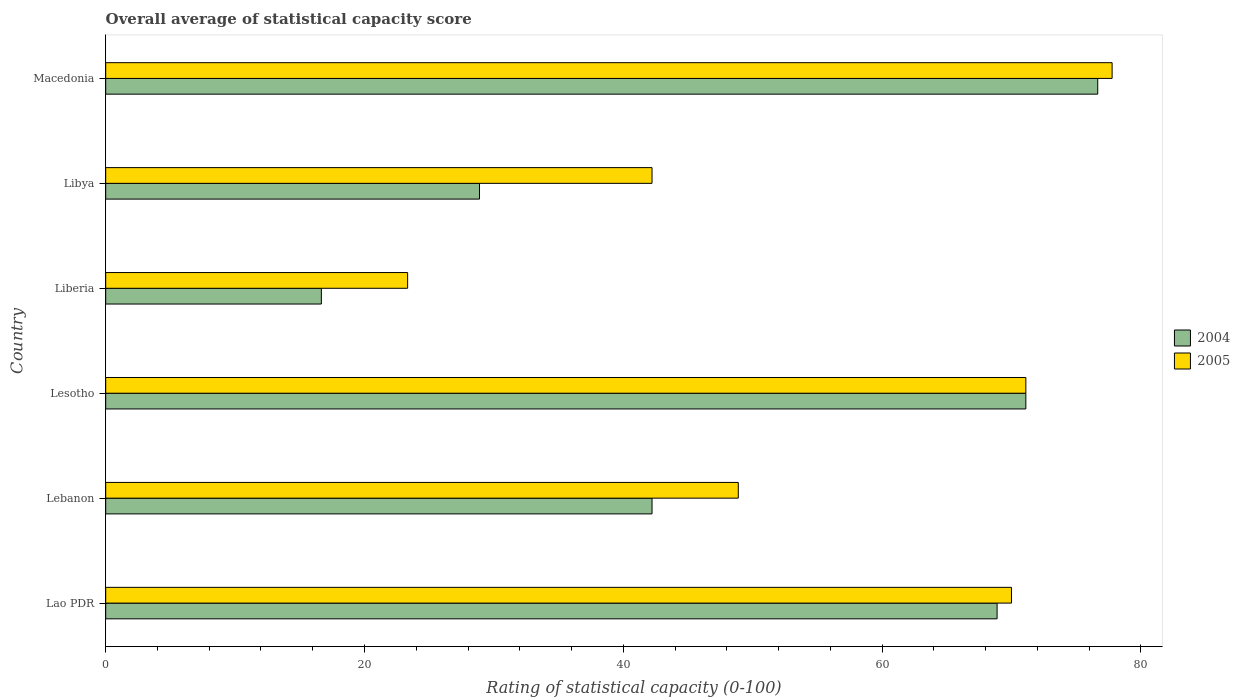How many different coloured bars are there?
Offer a terse response. 2. Are the number of bars on each tick of the Y-axis equal?
Offer a very short reply. Yes. How many bars are there on the 1st tick from the top?
Offer a terse response. 2. How many bars are there on the 2nd tick from the bottom?
Your response must be concise. 2. What is the label of the 2nd group of bars from the top?
Provide a succinct answer. Libya. In how many cases, is the number of bars for a given country not equal to the number of legend labels?
Provide a short and direct response. 0. What is the rating of statistical capacity in 2005 in Liberia?
Your answer should be very brief. 23.33. Across all countries, what is the maximum rating of statistical capacity in 2004?
Your response must be concise. 76.67. Across all countries, what is the minimum rating of statistical capacity in 2005?
Ensure brevity in your answer.  23.33. In which country was the rating of statistical capacity in 2004 maximum?
Your answer should be compact. Macedonia. In which country was the rating of statistical capacity in 2004 minimum?
Provide a short and direct response. Liberia. What is the total rating of statistical capacity in 2005 in the graph?
Make the answer very short. 333.33. What is the difference between the rating of statistical capacity in 2005 in Lebanon and that in Liberia?
Provide a succinct answer. 25.56. What is the difference between the rating of statistical capacity in 2004 in Lebanon and the rating of statistical capacity in 2005 in Lesotho?
Keep it short and to the point. -28.89. What is the average rating of statistical capacity in 2005 per country?
Provide a succinct answer. 55.56. What is the difference between the rating of statistical capacity in 2005 and rating of statistical capacity in 2004 in Lebanon?
Give a very brief answer. 6.67. In how many countries, is the rating of statistical capacity in 2004 greater than 64 ?
Offer a terse response. 3. What is the ratio of the rating of statistical capacity in 2005 in Lao PDR to that in Libya?
Offer a very short reply. 1.66. Is the rating of statistical capacity in 2004 in Libya less than that in Macedonia?
Provide a short and direct response. Yes. Is the difference between the rating of statistical capacity in 2005 in Lao PDR and Libya greater than the difference between the rating of statistical capacity in 2004 in Lao PDR and Libya?
Your answer should be very brief. No. What is the difference between the highest and the second highest rating of statistical capacity in 2004?
Provide a succinct answer. 5.56. What is the difference between the highest and the lowest rating of statistical capacity in 2005?
Your answer should be very brief. 54.44. In how many countries, is the rating of statistical capacity in 2004 greater than the average rating of statistical capacity in 2004 taken over all countries?
Your answer should be very brief. 3. Is the sum of the rating of statistical capacity in 2004 in Liberia and Libya greater than the maximum rating of statistical capacity in 2005 across all countries?
Make the answer very short. No. What does the 1st bar from the top in Libya represents?
Your answer should be compact. 2005. What does the 2nd bar from the bottom in Macedonia represents?
Offer a very short reply. 2005. How many bars are there?
Make the answer very short. 12. How many countries are there in the graph?
Your answer should be very brief. 6. What is the difference between two consecutive major ticks on the X-axis?
Offer a very short reply. 20. Are the values on the major ticks of X-axis written in scientific E-notation?
Provide a succinct answer. No. Does the graph contain grids?
Provide a succinct answer. No. Where does the legend appear in the graph?
Provide a succinct answer. Center right. How many legend labels are there?
Ensure brevity in your answer.  2. How are the legend labels stacked?
Provide a succinct answer. Vertical. What is the title of the graph?
Keep it short and to the point. Overall average of statistical capacity score. What is the label or title of the X-axis?
Your response must be concise. Rating of statistical capacity (0-100). What is the Rating of statistical capacity (0-100) of 2004 in Lao PDR?
Your response must be concise. 68.89. What is the Rating of statistical capacity (0-100) in 2005 in Lao PDR?
Ensure brevity in your answer.  70. What is the Rating of statistical capacity (0-100) of 2004 in Lebanon?
Ensure brevity in your answer.  42.22. What is the Rating of statistical capacity (0-100) of 2005 in Lebanon?
Give a very brief answer. 48.89. What is the Rating of statistical capacity (0-100) of 2004 in Lesotho?
Provide a succinct answer. 71.11. What is the Rating of statistical capacity (0-100) in 2005 in Lesotho?
Offer a very short reply. 71.11. What is the Rating of statistical capacity (0-100) of 2004 in Liberia?
Offer a terse response. 16.67. What is the Rating of statistical capacity (0-100) of 2005 in Liberia?
Offer a very short reply. 23.33. What is the Rating of statistical capacity (0-100) in 2004 in Libya?
Your response must be concise. 28.89. What is the Rating of statistical capacity (0-100) in 2005 in Libya?
Offer a terse response. 42.22. What is the Rating of statistical capacity (0-100) of 2004 in Macedonia?
Your answer should be compact. 76.67. What is the Rating of statistical capacity (0-100) of 2005 in Macedonia?
Give a very brief answer. 77.78. Across all countries, what is the maximum Rating of statistical capacity (0-100) in 2004?
Keep it short and to the point. 76.67. Across all countries, what is the maximum Rating of statistical capacity (0-100) in 2005?
Make the answer very short. 77.78. Across all countries, what is the minimum Rating of statistical capacity (0-100) of 2004?
Offer a terse response. 16.67. Across all countries, what is the minimum Rating of statistical capacity (0-100) in 2005?
Your response must be concise. 23.33. What is the total Rating of statistical capacity (0-100) of 2004 in the graph?
Your answer should be compact. 304.44. What is the total Rating of statistical capacity (0-100) in 2005 in the graph?
Your answer should be compact. 333.33. What is the difference between the Rating of statistical capacity (0-100) in 2004 in Lao PDR and that in Lebanon?
Make the answer very short. 26.67. What is the difference between the Rating of statistical capacity (0-100) in 2005 in Lao PDR and that in Lebanon?
Your response must be concise. 21.11. What is the difference between the Rating of statistical capacity (0-100) of 2004 in Lao PDR and that in Lesotho?
Make the answer very short. -2.22. What is the difference between the Rating of statistical capacity (0-100) of 2005 in Lao PDR and that in Lesotho?
Offer a very short reply. -1.11. What is the difference between the Rating of statistical capacity (0-100) of 2004 in Lao PDR and that in Liberia?
Provide a short and direct response. 52.22. What is the difference between the Rating of statistical capacity (0-100) in 2005 in Lao PDR and that in Liberia?
Your answer should be compact. 46.67. What is the difference between the Rating of statistical capacity (0-100) of 2004 in Lao PDR and that in Libya?
Your response must be concise. 40. What is the difference between the Rating of statistical capacity (0-100) in 2005 in Lao PDR and that in Libya?
Offer a terse response. 27.78. What is the difference between the Rating of statistical capacity (0-100) in 2004 in Lao PDR and that in Macedonia?
Offer a very short reply. -7.78. What is the difference between the Rating of statistical capacity (0-100) of 2005 in Lao PDR and that in Macedonia?
Provide a short and direct response. -7.78. What is the difference between the Rating of statistical capacity (0-100) of 2004 in Lebanon and that in Lesotho?
Offer a very short reply. -28.89. What is the difference between the Rating of statistical capacity (0-100) of 2005 in Lebanon and that in Lesotho?
Provide a succinct answer. -22.22. What is the difference between the Rating of statistical capacity (0-100) of 2004 in Lebanon and that in Liberia?
Give a very brief answer. 25.56. What is the difference between the Rating of statistical capacity (0-100) of 2005 in Lebanon and that in Liberia?
Offer a very short reply. 25.56. What is the difference between the Rating of statistical capacity (0-100) in 2004 in Lebanon and that in Libya?
Your answer should be compact. 13.33. What is the difference between the Rating of statistical capacity (0-100) of 2005 in Lebanon and that in Libya?
Give a very brief answer. 6.67. What is the difference between the Rating of statistical capacity (0-100) of 2004 in Lebanon and that in Macedonia?
Your response must be concise. -34.44. What is the difference between the Rating of statistical capacity (0-100) of 2005 in Lebanon and that in Macedonia?
Keep it short and to the point. -28.89. What is the difference between the Rating of statistical capacity (0-100) in 2004 in Lesotho and that in Liberia?
Offer a terse response. 54.44. What is the difference between the Rating of statistical capacity (0-100) of 2005 in Lesotho and that in Liberia?
Offer a terse response. 47.78. What is the difference between the Rating of statistical capacity (0-100) in 2004 in Lesotho and that in Libya?
Give a very brief answer. 42.22. What is the difference between the Rating of statistical capacity (0-100) in 2005 in Lesotho and that in Libya?
Your answer should be very brief. 28.89. What is the difference between the Rating of statistical capacity (0-100) in 2004 in Lesotho and that in Macedonia?
Provide a succinct answer. -5.56. What is the difference between the Rating of statistical capacity (0-100) in 2005 in Lesotho and that in Macedonia?
Your answer should be compact. -6.67. What is the difference between the Rating of statistical capacity (0-100) of 2004 in Liberia and that in Libya?
Make the answer very short. -12.22. What is the difference between the Rating of statistical capacity (0-100) in 2005 in Liberia and that in Libya?
Your response must be concise. -18.89. What is the difference between the Rating of statistical capacity (0-100) of 2004 in Liberia and that in Macedonia?
Ensure brevity in your answer.  -60. What is the difference between the Rating of statistical capacity (0-100) in 2005 in Liberia and that in Macedonia?
Offer a terse response. -54.44. What is the difference between the Rating of statistical capacity (0-100) in 2004 in Libya and that in Macedonia?
Make the answer very short. -47.78. What is the difference between the Rating of statistical capacity (0-100) of 2005 in Libya and that in Macedonia?
Ensure brevity in your answer.  -35.56. What is the difference between the Rating of statistical capacity (0-100) in 2004 in Lao PDR and the Rating of statistical capacity (0-100) in 2005 in Lesotho?
Provide a short and direct response. -2.22. What is the difference between the Rating of statistical capacity (0-100) in 2004 in Lao PDR and the Rating of statistical capacity (0-100) in 2005 in Liberia?
Provide a short and direct response. 45.56. What is the difference between the Rating of statistical capacity (0-100) in 2004 in Lao PDR and the Rating of statistical capacity (0-100) in 2005 in Libya?
Make the answer very short. 26.67. What is the difference between the Rating of statistical capacity (0-100) in 2004 in Lao PDR and the Rating of statistical capacity (0-100) in 2005 in Macedonia?
Your response must be concise. -8.89. What is the difference between the Rating of statistical capacity (0-100) of 2004 in Lebanon and the Rating of statistical capacity (0-100) of 2005 in Lesotho?
Your response must be concise. -28.89. What is the difference between the Rating of statistical capacity (0-100) in 2004 in Lebanon and the Rating of statistical capacity (0-100) in 2005 in Liberia?
Provide a succinct answer. 18.89. What is the difference between the Rating of statistical capacity (0-100) in 2004 in Lebanon and the Rating of statistical capacity (0-100) in 2005 in Libya?
Your answer should be compact. 0. What is the difference between the Rating of statistical capacity (0-100) in 2004 in Lebanon and the Rating of statistical capacity (0-100) in 2005 in Macedonia?
Provide a short and direct response. -35.56. What is the difference between the Rating of statistical capacity (0-100) in 2004 in Lesotho and the Rating of statistical capacity (0-100) in 2005 in Liberia?
Give a very brief answer. 47.78. What is the difference between the Rating of statistical capacity (0-100) in 2004 in Lesotho and the Rating of statistical capacity (0-100) in 2005 in Libya?
Keep it short and to the point. 28.89. What is the difference between the Rating of statistical capacity (0-100) in 2004 in Lesotho and the Rating of statistical capacity (0-100) in 2005 in Macedonia?
Keep it short and to the point. -6.67. What is the difference between the Rating of statistical capacity (0-100) of 2004 in Liberia and the Rating of statistical capacity (0-100) of 2005 in Libya?
Ensure brevity in your answer.  -25.56. What is the difference between the Rating of statistical capacity (0-100) in 2004 in Liberia and the Rating of statistical capacity (0-100) in 2005 in Macedonia?
Offer a very short reply. -61.11. What is the difference between the Rating of statistical capacity (0-100) of 2004 in Libya and the Rating of statistical capacity (0-100) of 2005 in Macedonia?
Give a very brief answer. -48.89. What is the average Rating of statistical capacity (0-100) in 2004 per country?
Offer a terse response. 50.74. What is the average Rating of statistical capacity (0-100) in 2005 per country?
Offer a very short reply. 55.56. What is the difference between the Rating of statistical capacity (0-100) of 2004 and Rating of statistical capacity (0-100) of 2005 in Lao PDR?
Your response must be concise. -1.11. What is the difference between the Rating of statistical capacity (0-100) of 2004 and Rating of statistical capacity (0-100) of 2005 in Lebanon?
Make the answer very short. -6.67. What is the difference between the Rating of statistical capacity (0-100) in 2004 and Rating of statistical capacity (0-100) in 2005 in Liberia?
Give a very brief answer. -6.67. What is the difference between the Rating of statistical capacity (0-100) of 2004 and Rating of statistical capacity (0-100) of 2005 in Libya?
Ensure brevity in your answer.  -13.33. What is the difference between the Rating of statistical capacity (0-100) in 2004 and Rating of statistical capacity (0-100) in 2005 in Macedonia?
Provide a short and direct response. -1.11. What is the ratio of the Rating of statistical capacity (0-100) of 2004 in Lao PDR to that in Lebanon?
Give a very brief answer. 1.63. What is the ratio of the Rating of statistical capacity (0-100) in 2005 in Lao PDR to that in Lebanon?
Make the answer very short. 1.43. What is the ratio of the Rating of statistical capacity (0-100) of 2004 in Lao PDR to that in Lesotho?
Offer a terse response. 0.97. What is the ratio of the Rating of statistical capacity (0-100) in 2005 in Lao PDR to that in Lesotho?
Give a very brief answer. 0.98. What is the ratio of the Rating of statistical capacity (0-100) of 2004 in Lao PDR to that in Liberia?
Offer a terse response. 4.13. What is the ratio of the Rating of statistical capacity (0-100) in 2005 in Lao PDR to that in Liberia?
Provide a succinct answer. 3. What is the ratio of the Rating of statistical capacity (0-100) in 2004 in Lao PDR to that in Libya?
Your answer should be compact. 2.38. What is the ratio of the Rating of statistical capacity (0-100) in 2005 in Lao PDR to that in Libya?
Your answer should be compact. 1.66. What is the ratio of the Rating of statistical capacity (0-100) in 2004 in Lao PDR to that in Macedonia?
Give a very brief answer. 0.9. What is the ratio of the Rating of statistical capacity (0-100) of 2004 in Lebanon to that in Lesotho?
Ensure brevity in your answer.  0.59. What is the ratio of the Rating of statistical capacity (0-100) in 2005 in Lebanon to that in Lesotho?
Offer a very short reply. 0.69. What is the ratio of the Rating of statistical capacity (0-100) of 2004 in Lebanon to that in Liberia?
Offer a terse response. 2.53. What is the ratio of the Rating of statistical capacity (0-100) of 2005 in Lebanon to that in Liberia?
Your response must be concise. 2.1. What is the ratio of the Rating of statistical capacity (0-100) of 2004 in Lebanon to that in Libya?
Your response must be concise. 1.46. What is the ratio of the Rating of statistical capacity (0-100) in 2005 in Lebanon to that in Libya?
Offer a very short reply. 1.16. What is the ratio of the Rating of statistical capacity (0-100) in 2004 in Lebanon to that in Macedonia?
Your response must be concise. 0.55. What is the ratio of the Rating of statistical capacity (0-100) in 2005 in Lebanon to that in Macedonia?
Your response must be concise. 0.63. What is the ratio of the Rating of statistical capacity (0-100) in 2004 in Lesotho to that in Liberia?
Offer a terse response. 4.27. What is the ratio of the Rating of statistical capacity (0-100) in 2005 in Lesotho to that in Liberia?
Make the answer very short. 3.05. What is the ratio of the Rating of statistical capacity (0-100) in 2004 in Lesotho to that in Libya?
Give a very brief answer. 2.46. What is the ratio of the Rating of statistical capacity (0-100) of 2005 in Lesotho to that in Libya?
Provide a short and direct response. 1.68. What is the ratio of the Rating of statistical capacity (0-100) in 2004 in Lesotho to that in Macedonia?
Offer a terse response. 0.93. What is the ratio of the Rating of statistical capacity (0-100) of 2005 in Lesotho to that in Macedonia?
Make the answer very short. 0.91. What is the ratio of the Rating of statistical capacity (0-100) of 2004 in Liberia to that in Libya?
Keep it short and to the point. 0.58. What is the ratio of the Rating of statistical capacity (0-100) in 2005 in Liberia to that in Libya?
Keep it short and to the point. 0.55. What is the ratio of the Rating of statistical capacity (0-100) of 2004 in Liberia to that in Macedonia?
Your response must be concise. 0.22. What is the ratio of the Rating of statistical capacity (0-100) of 2004 in Libya to that in Macedonia?
Make the answer very short. 0.38. What is the ratio of the Rating of statistical capacity (0-100) of 2005 in Libya to that in Macedonia?
Provide a short and direct response. 0.54. What is the difference between the highest and the second highest Rating of statistical capacity (0-100) in 2004?
Provide a short and direct response. 5.56. What is the difference between the highest and the lowest Rating of statistical capacity (0-100) of 2004?
Your response must be concise. 60. What is the difference between the highest and the lowest Rating of statistical capacity (0-100) in 2005?
Your response must be concise. 54.44. 